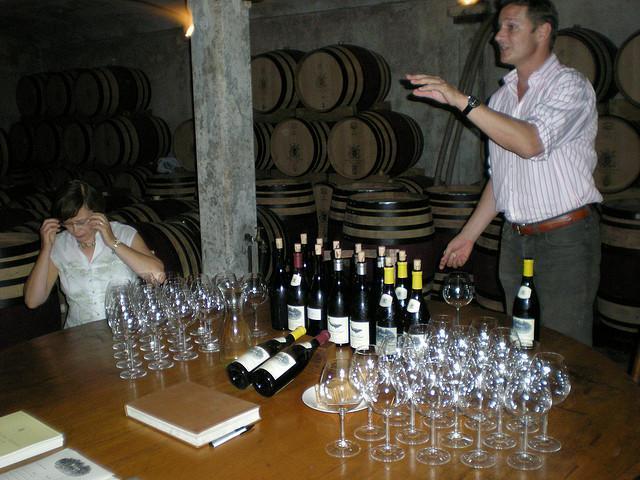How many wine glasses are there?
Give a very brief answer. 7. How many books are there?
Give a very brief answer. 2. How many people are in the photo?
Give a very brief answer. 2. How many chairs are visible?
Give a very brief answer. 0. 